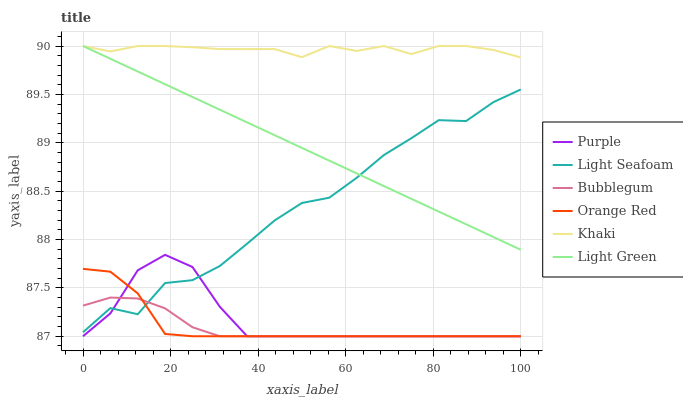Does Bubblegum have the minimum area under the curve?
Answer yes or no. Yes. Does Khaki have the maximum area under the curve?
Answer yes or no. Yes. Does Purple have the minimum area under the curve?
Answer yes or no. No. Does Purple have the maximum area under the curve?
Answer yes or no. No. Is Light Green the smoothest?
Answer yes or no. Yes. Is Light Seafoam the roughest?
Answer yes or no. Yes. Is Purple the smoothest?
Answer yes or no. No. Is Purple the roughest?
Answer yes or no. No. Does Purple have the lowest value?
Answer yes or no. Yes. Does Light Green have the lowest value?
Answer yes or no. No. Does Light Green have the highest value?
Answer yes or no. Yes. Does Purple have the highest value?
Answer yes or no. No. Is Bubblegum less than Khaki?
Answer yes or no. Yes. Is Khaki greater than Purple?
Answer yes or no. Yes. Does Light Seafoam intersect Purple?
Answer yes or no. Yes. Is Light Seafoam less than Purple?
Answer yes or no. No. Is Light Seafoam greater than Purple?
Answer yes or no. No. Does Bubblegum intersect Khaki?
Answer yes or no. No. 